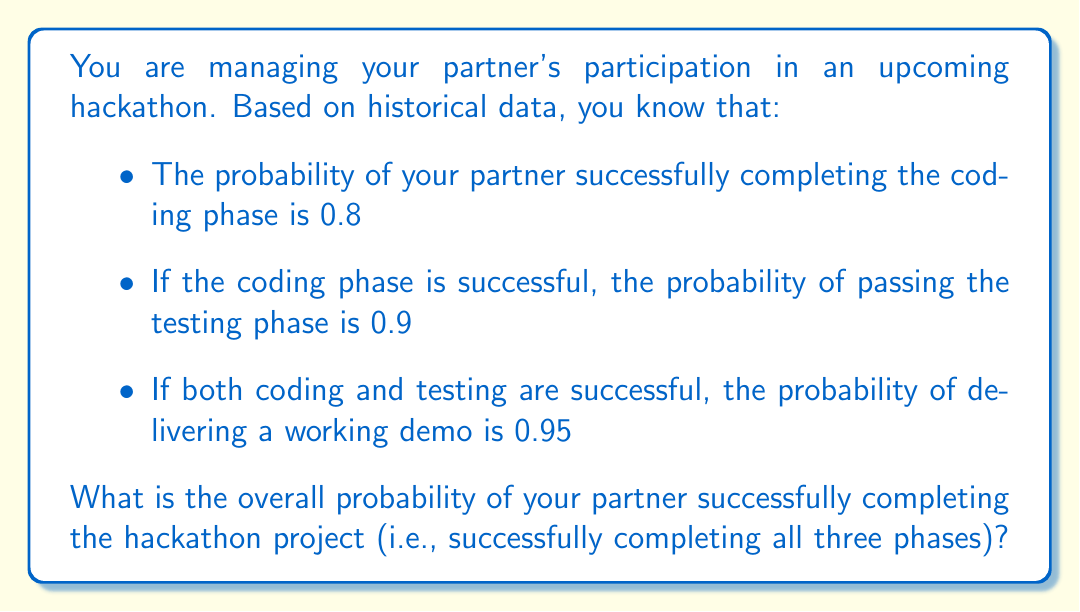Teach me how to tackle this problem. To solve this problem, we need to use the concept of conditional probability and the multiplication rule for independent events.

Let's define the events:
- A: Successfully completing the coding phase
- B: Passing the testing phase
- C: Delivering a working demo

We are given:
- P(A) = 0.8
- P(B|A) = 0.9 (probability of B given A)
- P(C|A ∩ B) = 0.95 (probability of C given both A and B)

To find the overall probability of successfully completing the project, we need to calculate P(A ∩ B ∩ C).

Using the multiplication rule:

$$ P(A \cap B \cap C) = P(A) \cdot P(B|A) \cdot P(C|A \cap B) $$

Substituting the given probabilities:

$$ P(A \cap B \cap C) = 0.8 \cdot 0.9 \cdot 0.95 $$

$$ P(A \cap B \cap C) = 0.684 $$

Therefore, the overall probability of successfully completing the hackathon project is 0.684 or 68.4%.
Answer: 0.684 or 68.4% 